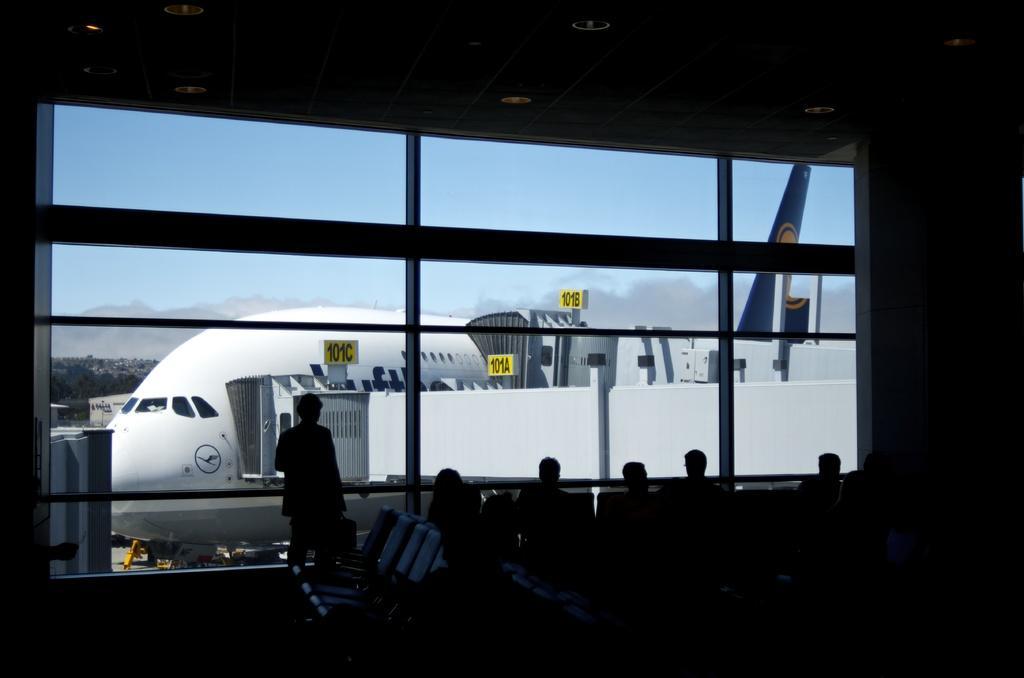How would you summarize this image in a sentence or two? This is an inside view of a room. At the bottom of the image I can see few people are sitting on the chairs and one person is standing. Here I can see a window through which we can see the outside view. In the outside, I can see an aeroplane on the land. In the background there are some trees and on the top I can see the sky. 